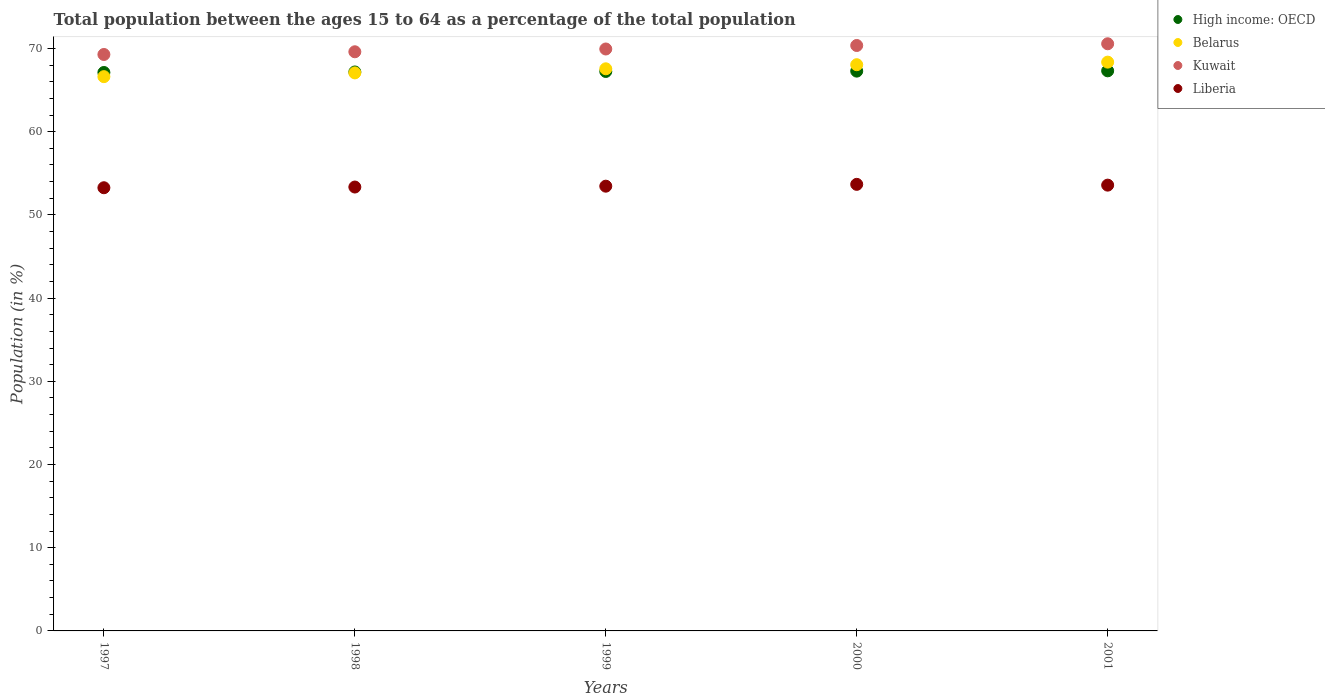How many different coloured dotlines are there?
Provide a succinct answer. 4. Is the number of dotlines equal to the number of legend labels?
Ensure brevity in your answer.  Yes. What is the percentage of the population ages 15 to 64 in Kuwait in 2001?
Provide a short and direct response. 70.57. Across all years, what is the maximum percentage of the population ages 15 to 64 in Kuwait?
Make the answer very short. 70.57. Across all years, what is the minimum percentage of the population ages 15 to 64 in Liberia?
Give a very brief answer. 53.26. In which year was the percentage of the population ages 15 to 64 in Liberia minimum?
Offer a terse response. 1997. What is the total percentage of the population ages 15 to 64 in High income: OECD in the graph?
Ensure brevity in your answer.  336.12. What is the difference between the percentage of the population ages 15 to 64 in Liberia in 1999 and that in 2001?
Keep it short and to the point. -0.12. What is the difference between the percentage of the population ages 15 to 64 in Kuwait in 1998 and the percentage of the population ages 15 to 64 in Belarus in 1999?
Keep it short and to the point. 2.05. What is the average percentage of the population ages 15 to 64 in Liberia per year?
Your answer should be very brief. 53.46. In the year 1999, what is the difference between the percentage of the population ages 15 to 64 in Liberia and percentage of the population ages 15 to 64 in Belarus?
Offer a terse response. -14.11. What is the ratio of the percentage of the population ages 15 to 64 in Belarus in 1999 to that in 2001?
Offer a terse response. 0.99. What is the difference between the highest and the second highest percentage of the population ages 15 to 64 in Belarus?
Offer a terse response. 0.31. What is the difference between the highest and the lowest percentage of the population ages 15 to 64 in Kuwait?
Offer a very short reply. 1.29. Is it the case that in every year, the sum of the percentage of the population ages 15 to 64 in Liberia and percentage of the population ages 15 to 64 in High income: OECD  is greater than the sum of percentage of the population ages 15 to 64 in Belarus and percentage of the population ages 15 to 64 in Kuwait?
Your answer should be compact. No. Is it the case that in every year, the sum of the percentage of the population ages 15 to 64 in High income: OECD and percentage of the population ages 15 to 64 in Liberia  is greater than the percentage of the population ages 15 to 64 in Belarus?
Provide a short and direct response. Yes. Does the percentage of the population ages 15 to 64 in Kuwait monotonically increase over the years?
Ensure brevity in your answer.  Yes. Is the percentage of the population ages 15 to 64 in Belarus strictly greater than the percentage of the population ages 15 to 64 in High income: OECD over the years?
Keep it short and to the point. No. How many dotlines are there?
Provide a succinct answer. 4. What is the difference between two consecutive major ticks on the Y-axis?
Your response must be concise. 10. How many legend labels are there?
Ensure brevity in your answer.  4. How are the legend labels stacked?
Keep it short and to the point. Vertical. What is the title of the graph?
Give a very brief answer. Total population between the ages 15 to 64 as a percentage of the total population. What is the label or title of the X-axis?
Give a very brief answer. Years. What is the Population (in %) of High income: OECD in 1997?
Ensure brevity in your answer.  67.11. What is the Population (in %) of Belarus in 1997?
Your response must be concise. 66.62. What is the Population (in %) of Kuwait in 1997?
Provide a succinct answer. 69.28. What is the Population (in %) of Liberia in 1997?
Your answer should be very brief. 53.26. What is the Population (in %) in High income: OECD in 1998?
Keep it short and to the point. 67.18. What is the Population (in %) of Belarus in 1998?
Keep it short and to the point. 67.07. What is the Population (in %) in Kuwait in 1998?
Offer a very short reply. 69.6. What is the Population (in %) in Liberia in 1998?
Give a very brief answer. 53.35. What is the Population (in %) of High income: OECD in 1999?
Make the answer very short. 67.24. What is the Population (in %) in Belarus in 1999?
Provide a succinct answer. 67.56. What is the Population (in %) in Kuwait in 1999?
Give a very brief answer. 69.94. What is the Population (in %) of Liberia in 1999?
Provide a short and direct response. 53.45. What is the Population (in %) in High income: OECD in 2000?
Offer a very short reply. 67.28. What is the Population (in %) in Belarus in 2000?
Give a very brief answer. 68.05. What is the Population (in %) of Kuwait in 2000?
Provide a short and direct response. 70.36. What is the Population (in %) in Liberia in 2000?
Ensure brevity in your answer.  53.67. What is the Population (in %) in High income: OECD in 2001?
Your answer should be compact. 67.31. What is the Population (in %) in Belarus in 2001?
Make the answer very short. 68.36. What is the Population (in %) of Kuwait in 2001?
Ensure brevity in your answer.  70.57. What is the Population (in %) of Liberia in 2001?
Give a very brief answer. 53.58. Across all years, what is the maximum Population (in %) in High income: OECD?
Provide a short and direct response. 67.31. Across all years, what is the maximum Population (in %) of Belarus?
Keep it short and to the point. 68.36. Across all years, what is the maximum Population (in %) of Kuwait?
Ensure brevity in your answer.  70.57. Across all years, what is the maximum Population (in %) in Liberia?
Your response must be concise. 53.67. Across all years, what is the minimum Population (in %) in High income: OECD?
Your response must be concise. 67.11. Across all years, what is the minimum Population (in %) of Belarus?
Keep it short and to the point. 66.62. Across all years, what is the minimum Population (in %) in Kuwait?
Your response must be concise. 69.28. Across all years, what is the minimum Population (in %) of Liberia?
Offer a very short reply. 53.26. What is the total Population (in %) in High income: OECD in the graph?
Your response must be concise. 336.12. What is the total Population (in %) of Belarus in the graph?
Keep it short and to the point. 337.65. What is the total Population (in %) of Kuwait in the graph?
Make the answer very short. 349.75. What is the total Population (in %) in Liberia in the graph?
Your answer should be very brief. 267.31. What is the difference between the Population (in %) of High income: OECD in 1997 and that in 1998?
Your response must be concise. -0.06. What is the difference between the Population (in %) of Belarus in 1997 and that in 1998?
Keep it short and to the point. -0.45. What is the difference between the Population (in %) in Kuwait in 1997 and that in 1998?
Ensure brevity in your answer.  -0.33. What is the difference between the Population (in %) in Liberia in 1997 and that in 1998?
Ensure brevity in your answer.  -0.09. What is the difference between the Population (in %) of High income: OECD in 1997 and that in 1999?
Your response must be concise. -0.12. What is the difference between the Population (in %) of Belarus in 1997 and that in 1999?
Provide a succinct answer. -0.94. What is the difference between the Population (in %) in Kuwait in 1997 and that in 1999?
Give a very brief answer. -0.66. What is the difference between the Population (in %) of Liberia in 1997 and that in 1999?
Provide a succinct answer. -0.19. What is the difference between the Population (in %) of High income: OECD in 1997 and that in 2000?
Offer a terse response. -0.16. What is the difference between the Population (in %) in Belarus in 1997 and that in 2000?
Your answer should be compact. -1.44. What is the difference between the Population (in %) in Kuwait in 1997 and that in 2000?
Give a very brief answer. -1.08. What is the difference between the Population (in %) in Liberia in 1997 and that in 2000?
Provide a succinct answer. -0.41. What is the difference between the Population (in %) in High income: OECD in 1997 and that in 2001?
Make the answer very short. -0.2. What is the difference between the Population (in %) in Belarus in 1997 and that in 2001?
Provide a succinct answer. -1.74. What is the difference between the Population (in %) in Kuwait in 1997 and that in 2001?
Provide a short and direct response. -1.29. What is the difference between the Population (in %) in Liberia in 1997 and that in 2001?
Your answer should be very brief. -0.31. What is the difference between the Population (in %) in High income: OECD in 1998 and that in 1999?
Give a very brief answer. -0.06. What is the difference between the Population (in %) of Belarus in 1998 and that in 1999?
Your answer should be compact. -0.49. What is the difference between the Population (in %) in Kuwait in 1998 and that in 1999?
Ensure brevity in your answer.  -0.33. What is the difference between the Population (in %) in Liberia in 1998 and that in 1999?
Provide a succinct answer. -0.1. What is the difference between the Population (in %) in High income: OECD in 1998 and that in 2000?
Give a very brief answer. -0.1. What is the difference between the Population (in %) of Belarus in 1998 and that in 2000?
Your answer should be compact. -0.98. What is the difference between the Population (in %) in Kuwait in 1998 and that in 2000?
Make the answer very short. -0.75. What is the difference between the Population (in %) in Liberia in 1998 and that in 2000?
Provide a short and direct response. -0.32. What is the difference between the Population (in %) in High income: OECD in 1998 and that in 2001?
Make the answer very short. -0.14. What is the difference between the Population (in %) in Belarus in 1998 and that in 2001?
Provide a succinct answer. -1.29. What is the difference between the Population (in %) of Kuwait in 1998 and that in 2001?
Your response must be concise. -0.96. What is the difference between the Population (in %) in Liberia in 1998 and that in 2001?
Your response must be concise. -0.23. What is the difference between the Population (in %) of High income: OECD in 1999 and that in 2000?
Ensure brevity in your answer.  -0.04. What is the difference between the Population (in %) of Belarus in 1999 and that in 2000?
Provide a succinct answer. -0.49. What is the difference between the Population (in %) of Kuwait in 1999 and that in 2000?
Make the answer very short. -0.42. What is the difference between the Population (in %) of Liberia in 1999 and that in 2000?
Your answer should be compact. -0.22. What is the difference between the Population (in %) of High income: OECD in 1999 and that in 2001?
Provide a short and direct response. -0.08. What is the difference between the Population (in %) of Belarus in 1999 and that in 2001?
Provide a short and direct response. -0.8. What is the difference between the Population (in %) of Kuwait in 1999 and that in 2001?
Your answer should be very brief. -0.63. What is the difference between the Population (in %) in Liberia in 1999 and that in 2001?
Provide a short and direct response. -0.12. What is the difference between the Population (in %) of High income: OECD in 2000 and that in 2001?
Ensure brevity in your answer.  -0.04. What is the difference between the Population (in %) in Belarus in 2000 and that in 2001?
Make the answer very short. -0.31. What is the difference between the Population (in %) of Kuwait in 2000 and that in 2001?
Make the answer very short. -0.21. What is the difference between the Population (in %) in Liberia in 2000 and that in 2001?
Offer a very short reply. 0.09. What is the difference between the Population (in %) of High income: OECD in 1997 and the Population (in %) of Belarus in 1998?
Your response must be concise. 0.05. What is the difference between the Population (in %) in High income: OECD in 1997 and the Population (in %) in Kuwait in 1998?
Give a very brief answer. -2.49. What is the difference between the Population (in %) of High income: OECD in 1997 and the Population (in %) of Liberia in 1998?
Keep it short and to the point. 13.77. What is the difference between the Population (in %) of Belarus in 1997 and the Population (in %) of Kuwait in 1998?
Offer a very short reply. -2.99. What is the difference between the Population (in %) of Belarus in 1997 and the Population (in %) of Liberia in 1998?
Make the answer very short. 13.27. What is the difference between the Population (in %) in Kuwait in 1997 and the Population (in %) in Liberia in 1998?
Provide a short and direct response. 15.93. What is the difference between the Population (in %) of High income: OECD in 1997 and the Population (in %) of Belarus in 1999?
Provide a succinct answer. -0.44. What is the difference between the Population (in %) of High income: OECD in 1997 and the Population (in %) of Kuwait in 1999?
Give a very brief answer. -2.82. What is the difference between the Population (in %) of High income: OECD in 1997 and the Population (in %) of Liberia in 1999?
Provide a short and direct response. 13.66. What is the difference between the Population (in %) in Belarus in 1997 and the Population (in %) in Kuwait in 1999?
Make the answer very short. -3.32. What is the difference between the Population (in %) in Belarus in 1997 and the Population (in %) in Liberia in 1999?
Ensure brevity in your answer.  13.16. What is the difference between the Population (in %) in Kuwait in 1997 and the Population (in %) in Liberia in 1999?
Provide a short and direct response. 15.83. What is the difference between the Population (in %) of High income: OECD in 1997 and the Population (in %) of Belarus in 2000?
Ensure brevity in your answer.  -0.94. What is the difference between the Population (in %) of High income: OECD in 1997 and the Population (in %) of Kuwait in 2000?
Your answer should be very brief. -3.24. What is the difference between the Population (in %) of High income: OECD in 1997 and the Population (in %) of Liberia in 2000?
Your response must be concise. 13.44. What is the difference between the Population (in %) of Belarus in 1997 and the Population (in %) of Kuwait in 2000?
Ensure brevity in your answer.  -3.74. What is the difference between the Population (in %) of Belarus in 1997 and the Population (in %) of Liberia in 2000?
Provide a succinct answer. 12.94. What is the difference between the Population (in %) of Kuwait in 1997 and the Population (in %) of Liberia in 2000?
Provide a succinct answer. 15.61. What is the difference between the Population (in %) in High income: OECD in 1997 and the Population (in %) in Belarus in 2001?
Your response must be concise. -1.24. What is the difference between the Population (in %) of High income: OECD in 1997 and the Population (in %) of Kuwait in 2001?
Your response must be concise. -3.45. What is the difference between the Population (in %) in High income: OECD in 1997 and the Population (in %) in Liberia in 2001?
Give a very brief answer. 13.54. What is the difference between the Population (in %) in Belarus in 1997 and the Population (in %) in Kuwait in 2001?
Offer a very short reply. -3.95. What is the difference between the Population (in %) in Belarus in 1997 and the Population (in %) in Liberia in 2001?
Your response must be concise. 13.04. What is the difference between the Population (in %) of Kuwait in 1997 and the Population (in %) of Liberia in 2001?
Your answer should be compact. 15.7. What is the difference between the Population (in %) in High income: OECD in 1998 and the Population (in %) in Belarus in 1999?
Your response must be concise. -0.38. What is the difference between the Population (in %) of High income: OECD in 1998 and the Population (in %) of Kuwait in 1999?
Offer a very short reply. -2.76. What is the difference between the Population (in %) in High income: OECD in 1998 and the Population (in %) in Liberia in 1999?
Offer a very short reply. 13.73. What is the difference between the Population (in %) of Belarus in 1998 and the Population (in %) of Kuwait in 1999?
Give a very brief answer. -2.87. What is the difference between the Population (in %) in Belarus in 1998 and the Population (in %) in Liberia in 1999?
Offer a terse response. 13.62. What is the difference between the Population (in %) in Kuwait in 1998 and the Population (in %) in Liberia in 1999?
Provide a short and direct response. 16.15. What is the difference between the Population (in %) in High income: OECD in 1998 and the Population (in %) in Belarus in 2000?
Offer a terse response. -0.87. What is the difference between the Population (in %) in High income: OECD in 1998 and the Population (in %) in Kuwait in 2000?
Offer a terse response. -3.18. What is the difference between the Population (in %) in High income: OECD in 1998 and the Population (in %) in Liberia in 2000?
Offer a very short reply. 13.51. What is the difference between the Population (in %) in Belarus in 1998 and the Population (in %) in Kuwait in 2000?
Your answer should be very brief. -3.29. What is the difference between the Population (in %) of Belarus in 1998 and the Population (in %) of Liberia in 2000?
Your response must be concise. 13.4. What is the difference between the Population (in %) in Kuwait in 1998 and the Population (in %) in Liberia in 2000?
Provide a short and direct response. 15.93. What is the difference between the Population (in %) in High income: OECD in 1998 and the Population (in %) in Belarus in 2001?
Ensure brevity in your answer.  -1.18. What is the difference between the Population (in %) of High income: OECD in 1998 and the Population (in %) of Kuwait in 2001?
Offer a terse response. -3.39. What is the difference between the Population (in %) of High income: OECD in 1998 and the Population (in %) of Liberia in 2001?
Your response must be concise. 13.6. What is the difference between the Population (in %) of Belarus in 1998 and the Population (in %) of Kuwait in 2001?
Make the answer very short. -3.5. What is the difference between the Population (in %) of Belarus in 1998 and the Population (in %) of Liberia in 2001?
Your answer should be compact. 13.49. What is the difference between the Population (in %) of Kuwait in 1998 and the Population (in %) of Liberia in 2001?
Offer a terse response. 16.03. What is the difference between the Population (in %) of High income: OECD in 1999 and the Population (in %) of Belarus in 2000?
Provide a succinct answer. -0.81. What is the difference between the Population (in %) in High income: OECD in 1999 and the Population (in %) in Kuwait in 2000?
Make the answer very short. -3.12. What is the difference between the Population (in %) of High income: OECD in 1999 and the Population (in %) of Liberia in 2000?
Your answer should be compact. 13.57. What is the difference between the Population (in %) of Belarus in 1999 and the Population (in %) of Kuwait in 2000?
Keep it short and to the point. -2.8. What is the difference between the Population (in %) in Belarus in 1999 and the Population (in %) in Liberia in 2000?
Your answer should be very brief. 13.89. What is the difference between the Population (in %) of Kuwait in 1999 and the Population (in %) of Liberia in 2000?
Your answer should be compact. 16.27. What is the difference between the Population (in %) in High income: OECD in 1999 and the Population (in %) in Belarus in 2001?
Your response must be concise. -1.12. What is the difference between the Population (in %) of High income: OECD in 1999 and the Population (in %) of Kuwait in 2001?
Give a very brief answer. -3.33. What is the difference between the Population (in %) in High income: OECD in 1999 and the Population (in %) in Liberia in 2001?
Your answer should be compact. 13.66. What is the difference between the Population (in %) in Belarus in 1999 and the Population (in %) in Kuwait in 2001?
Your response must be concise. -3.01. What is the difference between the Population (in %) of Belarus in 1999 and the Population (in %) of Liberia in 2001?
Ensure brevity in your answer.  13.98. What is the difference between the Population (in %) of Kuwait in 1999 and the Population (in %) of Liberia in 2001?
Give a very brief answer. 16.36. What is the difference between the Population (in %) in High income: OECD in 2000 and the Population (in %) in Belarus in 2001?
Give a very brief answer. -1.08. What is the difference between the Population (in %) of High income: OECD in 2000 and the Population (in %) of Kuwait in 2001?
Your answer should be compact. -3.29. What is the difference between the Population (in %) of High income: OECD in 2000 and the Population (in %) of Liberia in 2001?
Provide a short and direct response. 13.7. What is the difference between the Population (in %) in Belarus in 2000 and the Population (in %) in Kuwait in 2001?
Give a very brief answer. -2.52. What is the difference between the Population (in %) of Belarus in 2000 and the Population (in %) of Liberia in 2001?
Keep it short and to the point. 14.47. What is the difference between the Population (in %) of Kuwait in 2000 and the Population (in %) of Liberia in 2001?
Your response must be concise. 16.78. What is the average Population (in %) in High income: OECD per year?
Keep it short and to the point. 67.22. What is the average Population (in %) of Belarus per year?
Ensure brevity in your answer.  67.53. What is the average Population (in %) in Kuwait per year?
Your answer should be very brief. 69.95. What is the average Population (in %) in Liberia per year?
Offer a terse response. 53.46. In the year 1997, what is the difference between the Population (in %) in High income: OECD and Population (in %) in Belarus?
Make the answer very short. 0.5. In the year 1997, what is the difference between the Population (in %) in High income: OECD and Population (in %) in Kuwait?
Offer a very short reply. -2.16. In the year 1997, what is the difference between the Population (in %) of High income: OECD and Population (in %) of Liberia?
Give a very brief answer. 13.85. In the year 1997, what is the difference between the Population (in %) in Belarus and Population (in %) in Kuwait?
Ensure brevity in your answer.  -2.66. In the year 1997, what is the difference between the Population (in %) in Belarus and Population (in %) in Liberia?
Offer a terse response. 13.35. In the year 1997, what is the difference between the Population (in %) in Kuwait and Population (in %) in Liberia?
Your response must be concise. 16.02. In the year 1998, what is the difference between the Population (in %) of High income: OECD and Population (in %) of Belarus?
Ensure brevity in your answer.  0.11. In the year 1998, what is the difference between the Population (in %) of High income: OECD and Population (in %) of Kuwait?
Your answer should be very brief. -2.43. In the year 1998, what is the difference between the Population (in %) in High income: OECD and Population (in %) in Liberia?
Offer a very short reply. 13.83. In the year 1998, what is the difference between the Population (in %) in Belarus and Population (in %) in Kuwait?
Provide a short and direct response. -2.54. In the year 1998, what is the difference between the Population (in %) of Belarus and Population (in %) of Liberia?
Provide a succinct answer. 13.72. In the year 1998, what is the difference between the Population (in %) of Kuwait and Population (in %) of Liberia?
Your response must be concise. 16.26. In the year 1999, what is the difference between the Population (in %) in High income: OECD and Population (in %) in Belarus?
Offer a very short reply. -0.32. In the year 1999, what is the difference between the Population (in %) in High income: OECD and Population (in %) in Kuwait?
Keep it short and to the point. -2.7. In the year 1999, what is the difference between the Population (in %) in High income: OECD and Population (in %) in Liberia?
Give a very brief answer. 13.79. In the year 1999, what is the difference between the Population (in %) of Belarus and Population (in %) of Kuwait?
Provide a short and direct response. -2.38. In the year 1999, what is the difference between the Population (in %) in Belarus and Population (in %) in Liberia?
Ensure brevity in your answer.  14.11. In the year 1999, what is the difference between the Population (in %) in Kuwait and Population (in %) in Liberia?
Keep it short and to the point. 16.49. In the year 2000, what is the difference between the Population (in %) in High income: OECD and Population (in %) in Belarus?
Offer a very short reply. -0.77. In the year 2000, what is the difference between the Population (in %) in High income: OECD and Population (in %) in Kuwait?
Offer a very short reply. -3.08. In the year 2000, what is the difference between the Population (in %) of High income: OECD and Population (in %) of Liberia?
Your response must be concise. 13.61. In the year 2000, what is the difference between the Population (in %) in Belarus and Population (in %) in Kuwait?
Make the answer very short. -2.31. In the year 2000, what is the difference between the Population (in %) of Belarus and Population (in %) of Liberia?
Ensure brevity in your answer.  14.38. In the year 2000, what is the difference between the Population (in %) of Kuwait and Population (in %) of Liberia?
Your response must be concise. 16.69. In the year 2001, what is the difference between the Population (in %) in High income: OECD and Population (in %) in Belarus?
Offer a terse response. -1.04. In the year 2001, what is the difference between the Population (in %) in High income: OECD and Population (in %) in Kuwait?
Your response must be concise. -3.25. In the year 2001, what is the difference between the Population (in %) of High income: OECD and Population (in %) of Liberia?
Provide a succinct answer. 13.74. In the year 2001, what is the difference between the Population (in %) of Belarus and Population (in %) of Kuwait?
Make the answer very short. -2.21. In the year 2001, what is the difference between the Population (in %) in Belarus and Population (in %) in Liberia?
Offer a terse response. 14.78. In the year 2001, what is the difference between the Population (in %) in Kuwait and Population (in %) in Liberia?
Your answer should be very brief. 16.99. What is the ratio of the Population (in %) in High income: OECD in 1997 to that in 1998?
Your answer should be very brief. 1. What is the ratio of the Population (in %) of Kuwait in 1997 to that in 1998?
Make the answer very short. 1. What is the ratio of the Population (in %) in Liberia in 1997 to that in 1998?
Your response must be concise. 1. What is the ratio of the Population (in %) in Belarus in 1997 to that in 1999?
Your response must be concise. 0.99. What is the ratio of the Population (in %) of Kuwait in 1997 to that in 1999?
Your answer should be compact. 0.99. What is the ratio of the Population (in %) of Liberia in 1997 to that in 1999?
Your response must be concise. 1. What is the ratio of the Population (in %) in High income: OECD in 1997 to that in 2000?
Offer a very short reply. 1. What is the ratio of the Population (in %) of Belarus in 1997 to that in 2000?
Keep it short and to the point. 0.98. What is the ratio of the Population (in %) of Kuwait in 1997 to that in 2000?
Provide a succinct answer. 0.98. What is the ratio of the Population (in %) of High income: OECD in 1997 to that in 2001?
Offer a very short reply. 1. What is the ratio of the Population (in %) in Belarus in 1997 to that in 2001?
Make the answer very short. 0.97. What is the ratio of the Population (in %) in Kuwait in 1997 to that in 2001?
Ensure brevity in your answer.  0.98. What is the ratio of the Population (in %) in Liberia in 1997 to that in 2001?
Ensure brevity in your answer.  0.99. What is the ratio of the Population (in %) in High income: OECD in 1998 to that in 1999?
Offer a very short reply. 1. What is the ratio of the Population (in %) in Kuwait in 1998 to that in 1999?
Keep it short and to the point. 1. What is the ratio of the Population (in %) in High income: OECD in 1998 to that in 2000?
Offer a terse response. 1. What is the ratio of the Population (in %) of Belarus in 1998 to that in 2000?
Keep it short and to the point. 0.99. What is the ratio of the Population (in %) in Kuwait in 1998 to that in 2000?
Offer a terse response. 0.99. What is the ratio of the Population (in %) in Belarus in 1998 to that in 2001?
Provide a short and direct response. 0.98. What is the ratio of the Population (in %) of Kuwait in 1998 to that in 2001?
Your answer should be very brief. 0.99. What is the ratio of the Population (in %) of High income: OECD in 1999 to that in 2000?
Keep it short and to the point. 1. What is the ratio of the Population (in %) in High income: OECD in 1999 to that in 2001?
Make the answer very short. 1. What is the ratio of the Population (in %) in Belarus in 1999 to that in 2001?
Provide a succinct answer. 0.99. What is the ratio of the Population (in %) in Kuwait in 2000 to that in 2001?
Your answer should be compact. 1. What is the difference between the highest and the second highest Population (in %) in High income: OECD?
Offer a terse response. 0.04. What is the difference between the highest and the second highest Population (in %) in Belarus?
Offer a terse response. 0.31. What is the difference between the highest and the second highest Population (in %) in Kuwait?
Provide a succinct answer. 0.21. What is the difference between the highest and the second highest Population (in %) of Liberia?
Offer a very short reply. 0.09. What is the difference between the highest and the lowest Population (in %) in High income: OECD?
Your response must be concise. 0.2. What is the difference between the highest and the lowest Population (in %) in Belarus?
Offer a very short reply. 1.74. What is the difference between the highest and the lowest Population (in %) of Kuwait?
Make the answer very short. 1.29. What is the difference between the highest and the lowest Population (in %) in Liberia?
Keep it short and to the point. 0.41. 